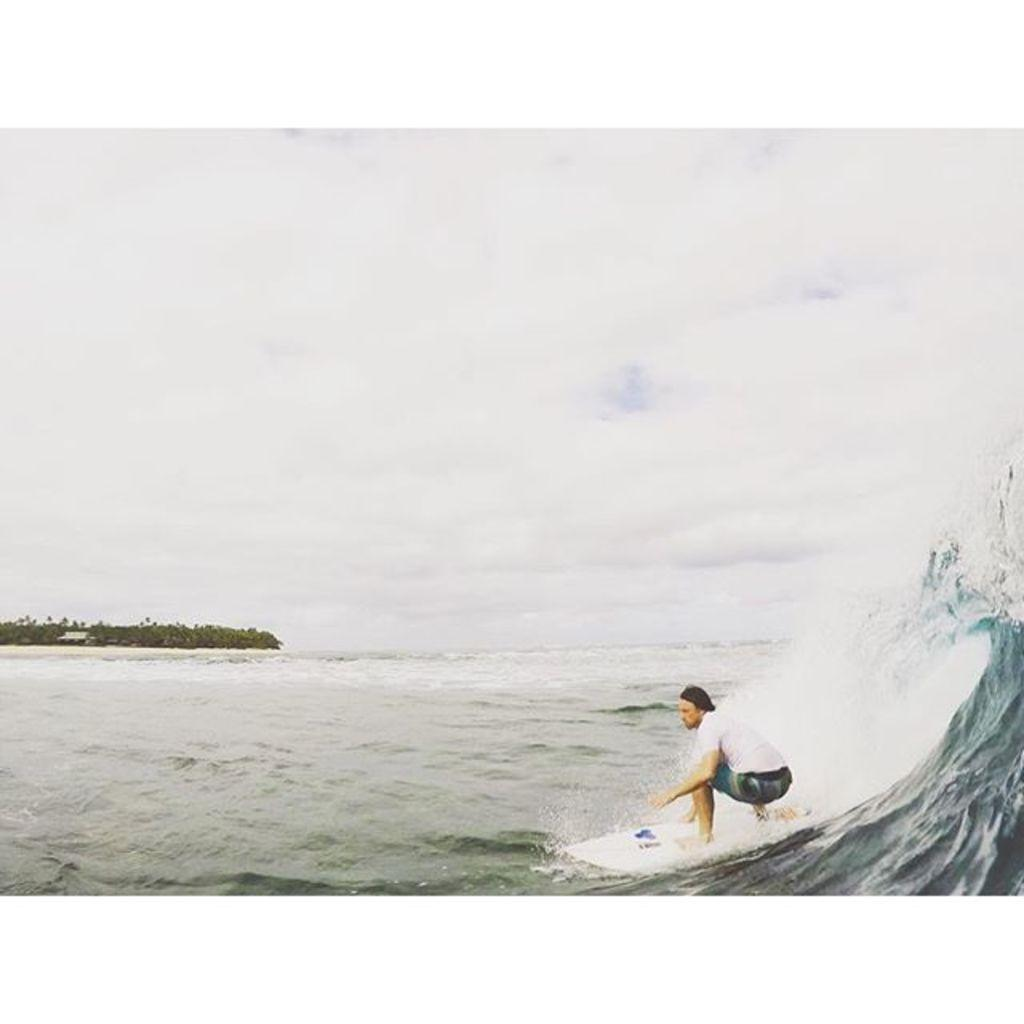What is the person in the image doing? The person is surfing in the image. Where is the person surfing? The person is on the water. What can be seen in the background of the image? There is sky, clouds, trees, water, and a few other objects visible in the background of the image. Can you hear the person laughing while surfing in the image? There is no sound present in the image, so it is not possible to determine if the person is laughing or not. 